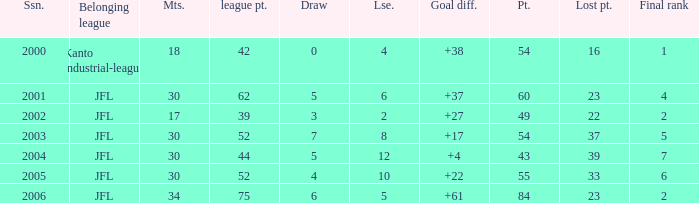I want the average lose for lost point more than 16 and goal difference less than 37 and point less than 43 None. 